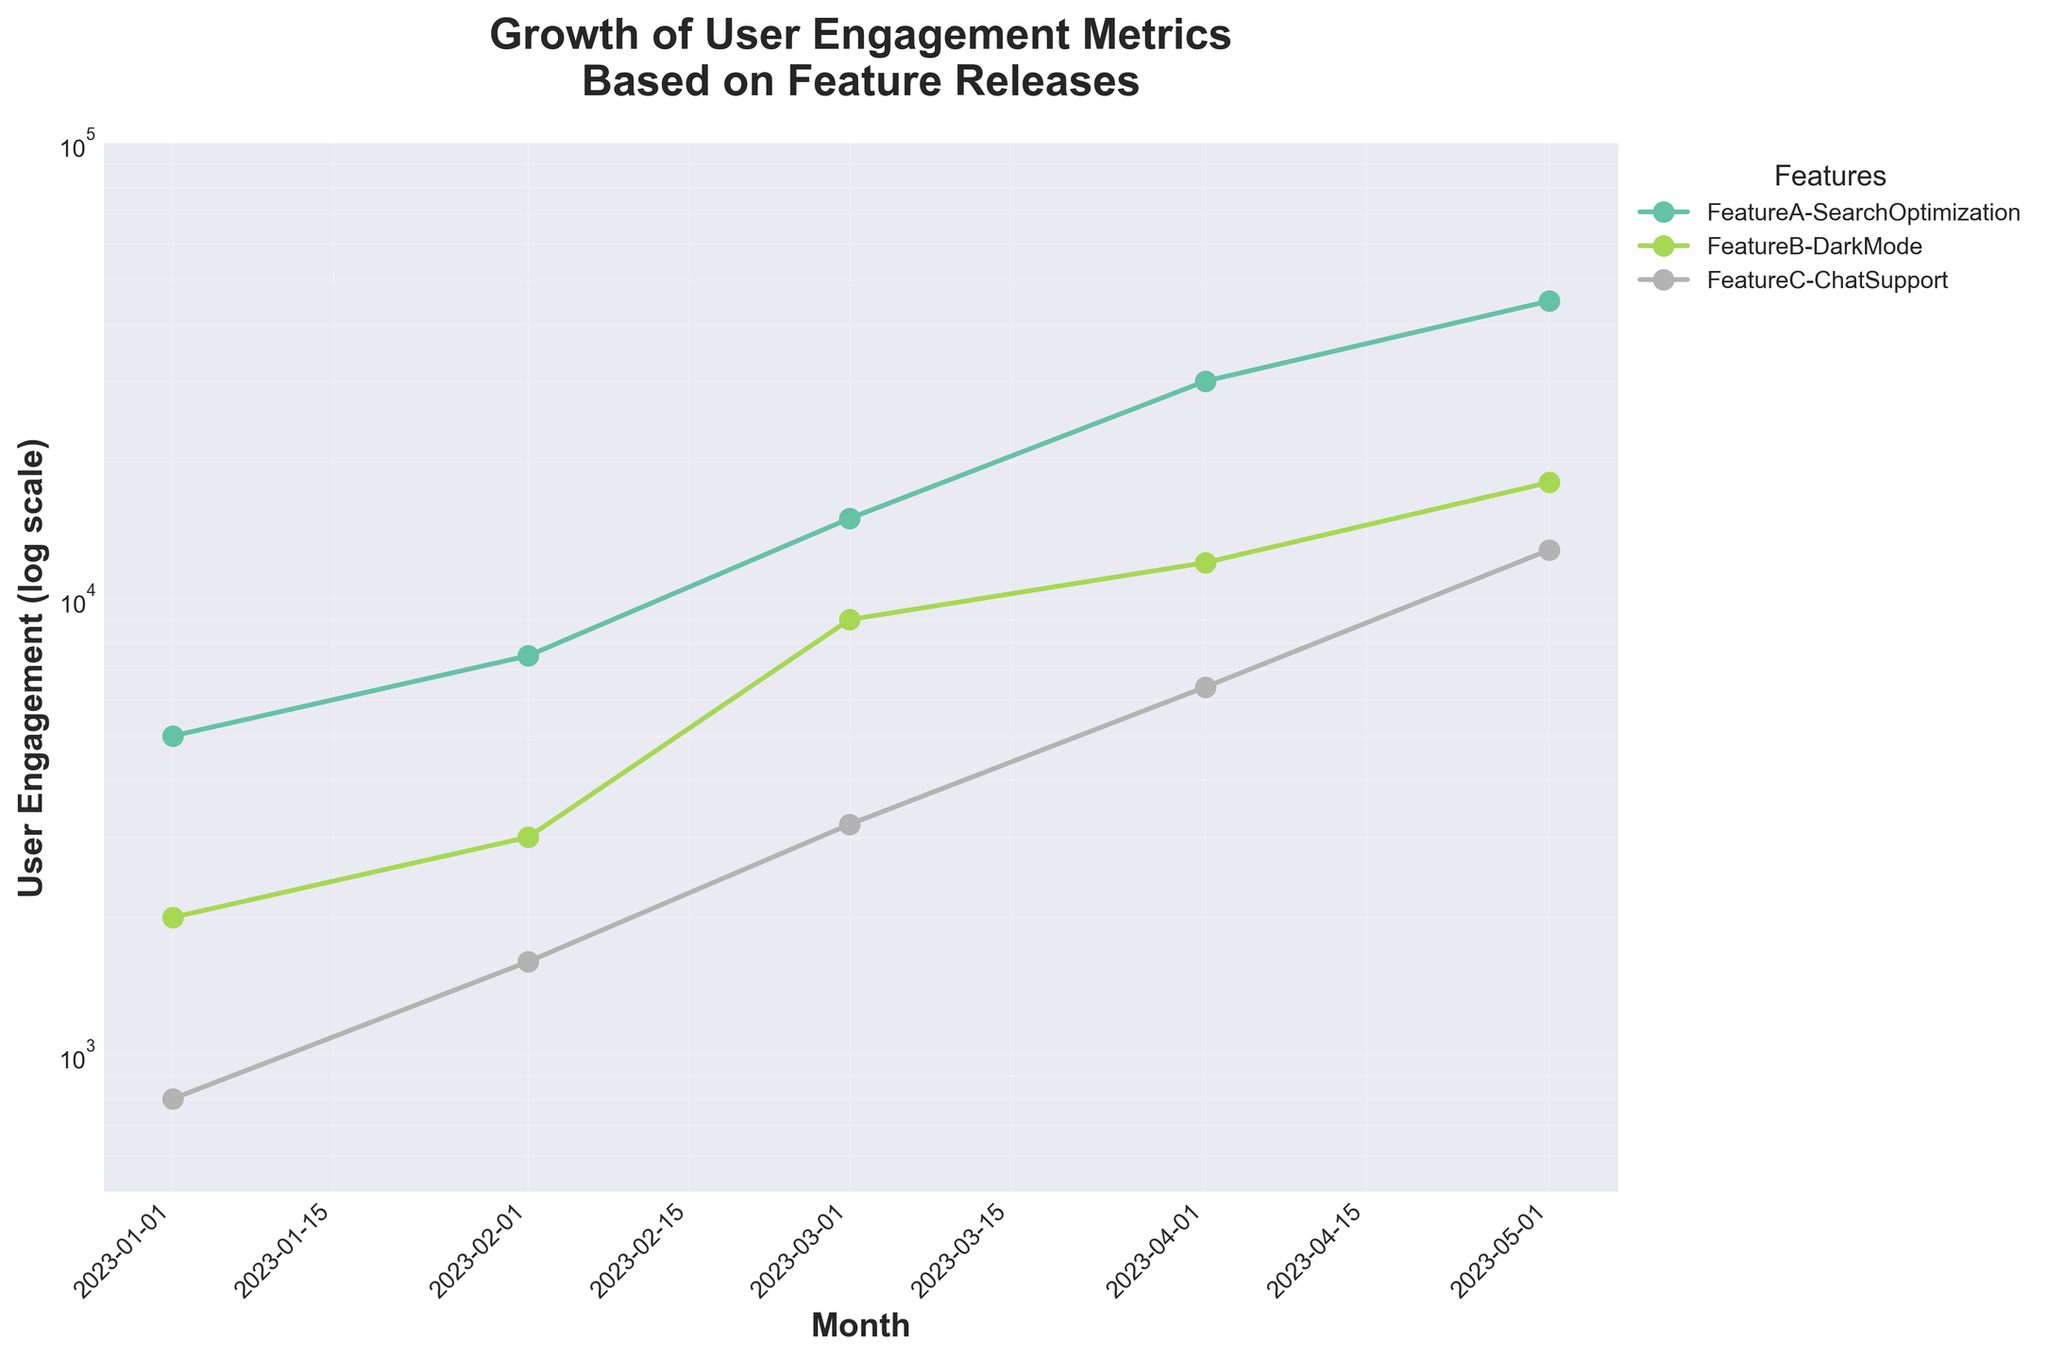What is the range of the y-axis? The y-axis has a logarithmic scale ranging from 500 to 100,000. You can see this in the figure where the lowest value is at 500 and the highest value is at 100,000.
Answer: 500 to 100,000 What is the title of the figure? The title is typically displayed at the top of the figure in bold and larger font size. In this case, it says "Growth of User Engagement Metrics\nBased on Feature Releases".
Answer: Growth of User Engagement Metrics\nBased on Feature Releases How many unique features are represented in the graph? Each line in the plot represents a unique feature. By observing the legend to the right of the plot, we can count three unique features: "FeatureA-SearchOptimization", "FeatureB-DarkMode", and "FeatureC-ChatSupport".
Answer: 3 Which feature shows the highest user engagement in May 2023? By following the lines to the right-most point corresponding to May 2023, we can see that "FeatureA-SearchOptimization" has the highest value.
Answer: FeatureA-SearchOptimization What color represents "FeatureB-DarkMode"? The legend on the right side of the plot assigns colors to each feature. "FeatureB-DarkMode" is shown in green.
Answer: Green By how much did user engagement of "FeatureA-SearchOptimization" grow between January and May 2023? The user engagement for "FeatureA-SearchOptimization" was 5,000 in January and 45,000 in May. The difference is 45,000 - 5,000 = 40,000.
Answer: 40,000 Which feature had the smallest user engagement in January 2023? Looking at the first data point for each line, "FeatureC-ChatSupport" has the smallest value at 800 in January 2023.
Answer: FeatureC-ChatSupport What is the average user engagement for "FeatureC-ChatSupport" over the time period? First, sum the user engagement values for "FeatureC-ChatSupport": 800 + 1600 + 3200 + 6400 + 12800 = 24,800. There are 5 months, so the average is 24,800 / 5.
Answer: 4,960 How does the user engagement growth of "FeatureB-DarkMode" compare to "FeatureC-ChatSupport"? "FeatureB-DarkMode" starts at 2,000 in January and rises to 18,000 in May, an increase of 18,000 - 2,000 = 16,000. "FeatureC-ChatSupport" starts at 800 in January and rises to 12,800 in May, an increase of 12,800 - 800 = 12,000. Therefore, "FeatureB-DarkMode" grew by 4,000 more than "FeatureC-ChatSupport".
Answer: FeatureB-DarkMode grew by 4,000 more Which month shows the highest increase in user engagement for "FeatureB-DarkMode"? Observing the values for each month, the biggest jump is between February and March (from 3,000 to 9,000). The increase is 9,000 - 3,000 = 6,000 in March.
Answer: March 